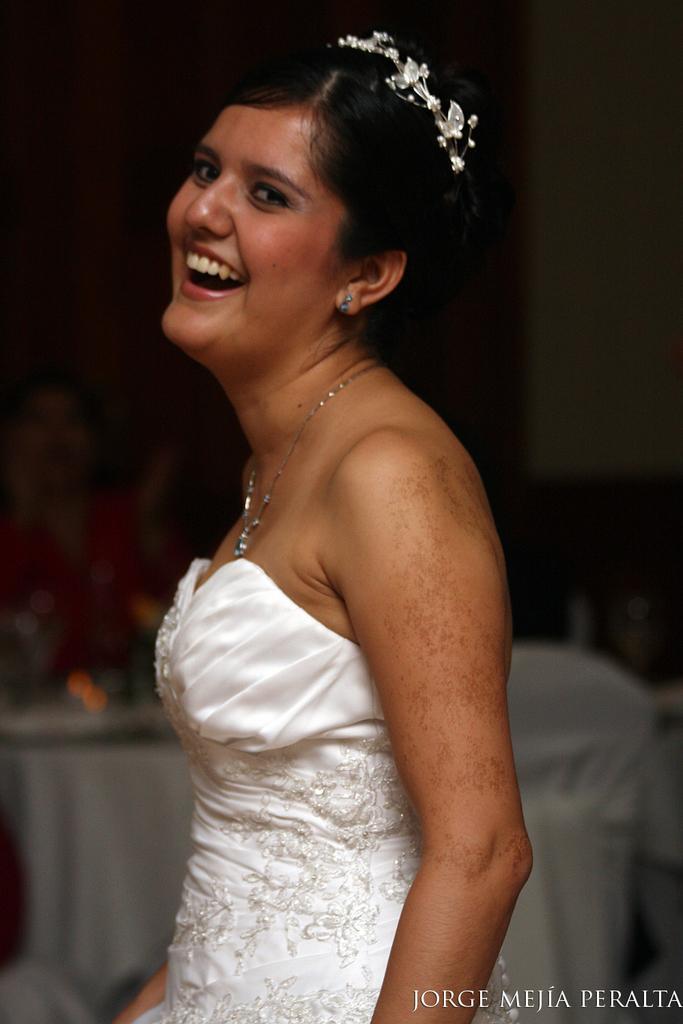Describe this image in one or two sentences. In this picture we can see a woman smiling and in the background we can see some objects and it is dark. 